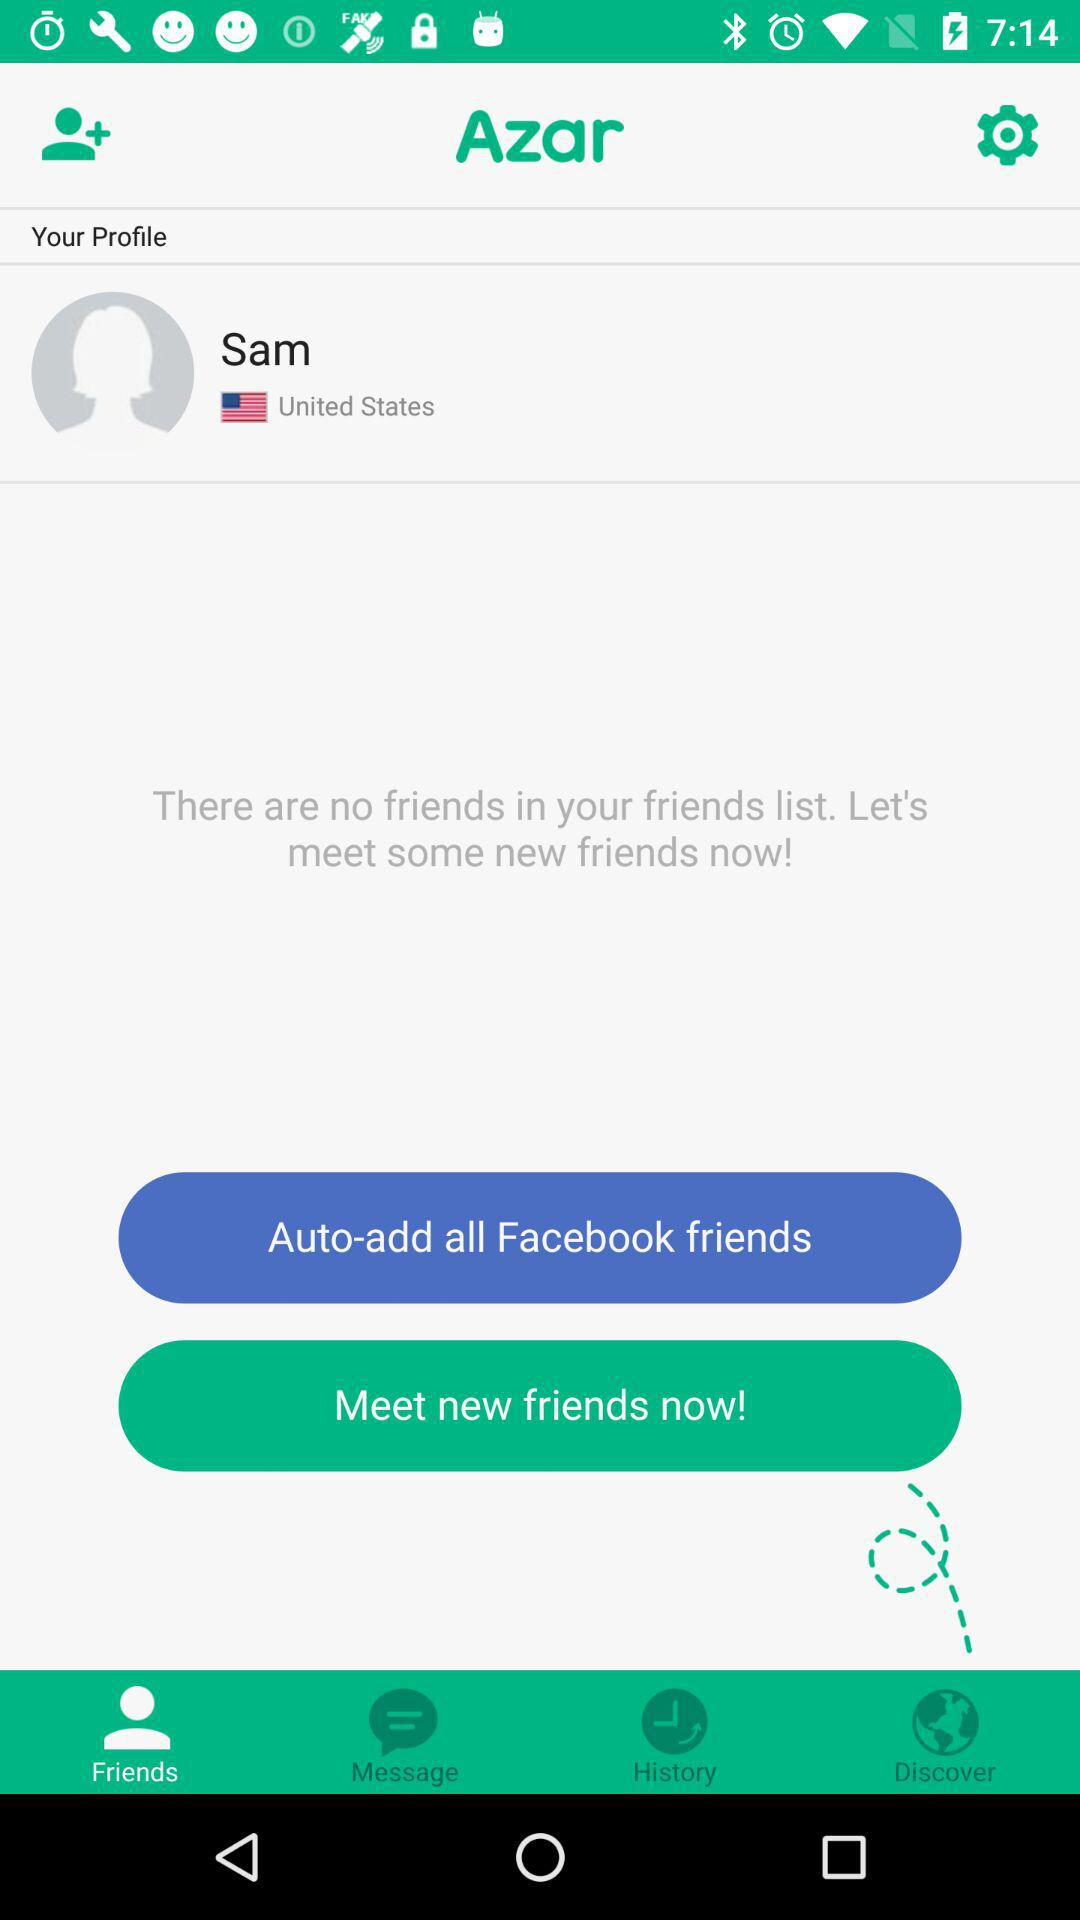What is the location? The location is the United States. 